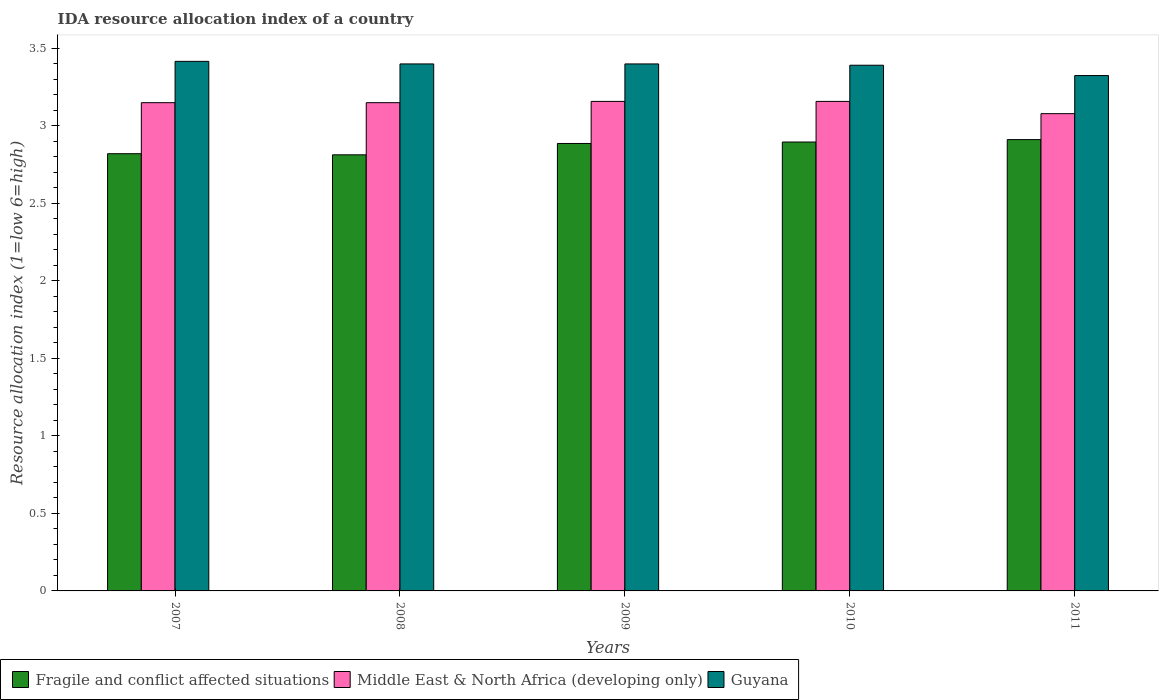How many groups of bars are there?
Your answer should be compact. 5. How many bars are there on the 1st tick from the right?
Provide a succinct answer. 3. What is the label of the 3rd group of bars from the left?
Provide a short and direct response. 2009. What is the IDA resource allocation index in Fragile and conflict affected situations in 2008?
Give a very brief answer. 2.81. Across all years, what is the maximum IDA resource allocation index in Guyana?
Offer a very short reply. 3.42. Across all years, what is the minimum IDA resource allocation index in Guyana?
Your answer should be compact. 3.33. In which year was the IDA resource allocation index in Fragile and conflict affected situations minimum?
Provide a short and direct response. 2008. What is the total IDA resource allocation index in Guyana in the graph?
Your response must be concise. 16.93. What is the difference between the IDA resource allocation index in Middle East & North Africa (developing only) in 2008 and that in 2011?
Give a very brief answer. 0.07. What is the difference between the IDA resource allocation index in Middle East & North Africa (developing only) in 2007 and the IDA resource allocation index in Guyana in 2010?
Your response must be concise. -0.24. What is the average IDA resource allocation index in Guyana per year?
Keep it short and to the point. 3.39. In the year 2008, what is the difference between the IDA resource allocation index in Fragile and conflict affected situations and IDA resource allocation index in Middle East & North Africa (developing only)?
Give a very brief answer. -0.34. In how many years, is the IDA resource allocation index in Fragile and conflict affected situations greater than 2.4?
Keep it short and to the point. 5. What is the ratio of the IDA resource allocation index in Guyana in 2009 to that in 2010?
Ensure brevity in your answer.  1. What is the difference between the highest and the second highest IDA resource allocation index in Fragile and conflict affected situations?
Keep it short and to the point. 0.02. What is the difference between the highest and the lowest IDA resource allocation index in Guyana?
Ensure brevity in your answer.  0.09. In how many years, is the IDA resource allocation index in Fragile and conflict affected situations greater than the average IDA resource allocation index in Fragile and conflict affected situations taken over all years?
Offer a terse response. 3. What does the 2nd bar from the left in 2010 represents?
Provide a short and direct response. Middle East & North Africa (developing only). What does the 1st bar from the right in 2011 represents?
Provide a short and direct response. Guyana. How many bars are there?
Make the answer very short. 15. Are all the bars in the graph horizontal?
Your response must be concise. No. What is the difference between two consecutive major ticks on the Y-axis?
Provide a succinct answer. 0.5. Are the values on the major ticks of Y-axis written in scientific E-notation?
Your response must be concise. No. Does the graph contain any zero values?
Ensure brevity in your answer.  No. Does the graph contain grids?
Your response must be concise. No. How many legend labels are there?
Offer a very short reply. 3. How are the legend labels stacked?
Your answer should be very brief. Horizontal. What is the title of the graph?
Offer a very short reply. IDA resource allocation index of a country. What is the label or title of the X-axis?
Keep it short and to the point. Years. What is the label or title of the Y-axis?
Your answer should be compact. Resource allocation index (1=low 6=high). What is the Resource allocation index (1=low 6=high) in Fragile and conflict affected situations in 2007?
Give a very brief answer. 2.82. What is the Resource allocation index (1=low 6=high) in Middle East & North Africa (developing only) in 2007?
Keep it short and to the point. 3.15. What is the Resource allocation index (1=low 6=high) in Guyana in 2007?
Give a very brief answer. 3.42. What is the Resource allocation index (1=low 6=high) of Fragile and conflict affected situations in 2008?
Give a very brief answer. 2.81. What is the Resource allocation index (1=low 6=high) in Middle East & North Africa (developing only) in 2008?
Ensure brevity in your answer.  3.15. What is the Resource allocation index (1=low 6=high) in Fragile and conflict affected situations in 2009?
Give a very brief answer. 2.89. What is the Resource allocation index (1=low 6=high) of Middle East & North Africa (developing only) in 2009?
Your response must be concise. 3.16. What is the Resource allocation index (1=low 6=high) of Guyana in 2009?
Provide a short and direct response. 3.4. What is the Resource allocation index (1=low 6=high) in Fragile and conflict affected situations in 2010?
Offer a terse response. 2.9. What is the Resource allocation index (1=low 6=high) of Middle East & North Africa (developing only) in 2010?
Ensure brevity in your answer.  3.16. What is the Resource allocation index (1=low 6=high) in Guyana in 2010?
Offer a terse response. 3.39. What is the Resource allocation index (1=low 6=high) in Fragile and conflict affected situations in 2011?
Make the answer very short. 2.91. What is the Resource allocation index (1=low 6=high) of Middle East & North Africa (developing only) in 2011?
Ensure brevity in your answer.  3.08. What is the Resource allocation index (1=low 6=high) in Guyana in 2011?
Offer a very short reply. 3.33. Across all years, what is the maximum Resource allocation index (1=low 6=high) in Fragile and conflict affected situations?
Offer a very short reply. 2.91. Across all years, what is the maximum Resource allocation index (1=low 6=high) of Middle East & North Africa (developing only)?
Offer a very short reply. 3.16. Across all years, what is the maximum Resource allocation index (1=low 6=high) of Guyana?
Keep it short and to the point. 3.42. Across all years, what is the minimum Resource allocation index (1=low 6=high) in Fragile and conflict affected situations?
Provide a succinct answer. 2.81. Across all years, what is the minimum Resource allocation index (1=low 6=high) in Middle East & North Africa (developing only)?
Your answer should be very brief. 3.08. Across all years, what is the minimum Resource allocation index (1=low 6=high) in Guyana?
Provide a short and direct response. 3.33. What is the total Resource allocation index (1=low 6=high) in Fragile and conflict affected situations in the graph?
Provide a succinct answer. 14.33. What is the total Resource allocation index (1=low 6=high) in Middle East & North Africa (developing only) in the graph?
Offer a very short reply. 15.7. What is the total Resource allocation index (1=low 6=high) in Guyana in the graph?
Provide a succinct answer. 16.93. What is the difference between the Resource allocation index (1=low 6=high) in Fragile and conflict affected situations in 2007 and that in 2008?
Provide a short and direct response. 0.01. What is the difference between the Resource allocation index (1=low 6=high) in Guyana in 2007 and that in 2008?
Your answer should be compact. 0.02. What is the difference between the Resource allocation index (1=low 6=high) of Fragile and conflict affected situations in 2007 and that in 2009?
Your answer should be compact. -0.07. What is the difference between the Resource allocation index (1=low 6=high) of Middle East & North Africa (developing only) in 2007 and that in 2009?
Your answer should be compact. -0.01. What is the difference between the Resource allocation index (1=low 6=high) in Guyana in 2007 and that in 2009?
Offer a very short reply. 0.02. What is the difference between the Resource allocation index (1=low 6=high) of Fragile and conflict affected situations in 2007 and that in 2010?
Provide a short and direct response. -0.08. What is the difference between the Resource allocation index (1=low 6=high) of Middle East & North Africa (developing only) in 2007 and that in 2010?
Keep it short and to the point. -0.01. What is the difference between the Resource allocation index (1=low 6=high) in Guyana in 2007 and that in 2010?
Ensure brevity in your answer.  0.03. What is the difference between the Resource allocation index (1=low 6=high) of Fragile and conflict affected situations in 2007 and that in 2011?
Your answer should be very brief. -0.09. What is the difference between the Resource allocation index (1=low 6=high) of Middle East & North Africa (developing only) in 2007 and that in 2011?
Keep it short and to the point. 0.07. What is the difference between the Resource allocation index (1=low 6=high) in Guyana in 2007 and that in 2011?
Your answer should be compact. 0.09. What is the difference between the Resource allocation index (1=low 6=high) in Fragile and conflict affected situations in 2008 and that in 2009?
Offer a very short reply. -0.07. What is the difference between the Resource allocation index (1=low 6=high) of Middle East & North Africa (developing only) in 2008 and that in 2009?
Offer a very short reply. -0.01. What is the difference between the Resource allocation index (1=low 6=high) of Guyana in 2008 and that in 2009?
Your response must be concise. 0. What is the difference between the Resource allocation index (1=low 6=high) in Fragile and conflict affected situations in 2008 and that in 2010?
Your answer should be compact. -0.08. What is the difference between the Resource allocation index (1=low 6=high) of Middle East & North Africa (developing only) in 2008 and that in 2010?
Provide a short and direct response. -0.01. What is the difference between the Resource allocation index (1=low 6=high) in Guyana in 2008 and that in 2010?
Provide a succinct answer. 0.01. What is the difference between the Resource allocation index (1=low 6=high) of Fragile and conflict affected situations in 2008 and that in 2011?
Keep it short and to the point. -0.1. What is the difference between the Resource allocation index (1=low 6=high) in Middle East & North Africa (developing only) in 2008 and that in 2011?
Offer a very short reply. 0.07. What is the difference between the Resource allocation index (1=low 6=high) of Guyana in 2008 and that in 2011?
Offer a very short reply. 0.07. What is the difference between the Resource allocation index (1=low 6=high) of Fragile and conflict affected situations in 2009 and that in 2010?
Your answer should be compact. -0.01. What is the difference between the Resource allocation index (1=low 6=high) in Guyana in 2009 and that in 2010?
Offer a very short reply. 0.01. What is the difference between the Resource allocation index (1=low 6=high) in Fragile and conflict affected situations in 2009 and that in 2011?
Give a very brief answer. -0.03. What is the difference between the Resource allocation index (1=low 6=high) in Middle East & North Africa (developing only) in 2009 and that in 2011?
Your response must be concise. 0.08. What is the difference between the Resource allocation index (1=low 6=high) of Guyana in 2009 and that in 2011?
Make the answer very short. 0.07. What is the difference between the Resource allocation index (1=low 6=high) in Fragile and conflict affected situations in 2010 and that in 2011?
Provide a short and direct response. -0.02. What is the difference between the Resource allocation index (1=low 6=high) in Middle East & North Africa (developing only) in 2010 and that in 2011?
Offer a terse response. 0.08. What is the difference between the Resource allocation index (1=low 6=high) of Guyana in 2010 and that in 2011?
Give a very brief answer. 0.07. What is the difference between the Resource allocation index (1=low 6=high) in Fragile and conflict affected situations in 2007 and the Resource allocation index (1=low 6=high) in Middle East & North Africa (developing only) in 2008?
Offer a very short reply. -0.33. What is the difference between the Resource allocation index (1=low 6=high) in Fragile and conflict affected situations in 2007 and the Resource allocation index (1=low 6=high) in Guyana in 2008?
Give a very brief answer. -0.58. What is the difference between the Resource allocation index (1=low 6=high) in Middle East & North Africa (developing only) in 2007 and the Resource allocation index (1=low 6=high) in Guyana in 2008?
Offer a very short reply. -0.25. What is the difference between the Resource allocation index (1=low 6=high) in Fragile and conflict affected situations in 2007 and the Resource allocation index (1=low 6=high) in Middle East & North Africa (developing only) in 2009?
Keep it short and to the point. -0.34. What is the difference between the Resource allocation index (1=low 6=high) in Fragile and conflict affected situations in 2007 and the Resource allocation index (1=low 6=high) in Guyana in 2009?
Ensure brevity in your answer.  -0.58. What is the difference between the Resource allocation index (1=low 6=high) of Fragile and conflict affected situations in 2007 and the Resource allocation index (1=low 6=high) of Middle East & North Africa (developing only) in 2010?
Offer a very short reply. -0.34. What is the difference between the Resource allocation index (1=low 6=high) of Fragile and conflict affected situations in 2007 and the Resource allocation index (1=low 6=high) of Guyana in 2010?
Keep it short and to the point. -0.57. What is the difference between the Resource allocation index (1=low 6=high) in Middle East & North Africa (developing only) in 2007 and the Resource allocation index (1=low 6=high) in Guyana in 2010?
Offer a very short reply. -0.24. What is the difference between the Resource allocation index (1=low 6=high) in Fragile and conflict affected situations in 2007 and the Resource allocation index (1=low 6=high) in Middle East & North Africa (developing only) in 2011?
Provide a short and direct response. -0.26. What is the difference between the Resource allocation index (1=low 6=high) of Fragile and conflict affected situations in 2007 and the Resource allocation index (1=low 6=high) of Guyana in 2011?
Provide a succinct answer. -0.5. What is the difference between the Resource allocation index (1=low 6=high) of Middle East & North Africa (developing only) in 2007 and the Resource allocation index (1=low 6=high) of Guyana in 2011?
Offer a terse response. -0.17. What is the difference between the Resource allocation index (1=low 6=high) of Fragile and conflict affected situations in 2008 and the Resource allocation index (1=low 6=high) of Middle East & North Africa (developing only) in 2009?
Provide a succinct answer. -0.34. What is the difference between the Resource allocation index (1=low 6=high) of Fragile and conflict affected situations in 2008 and the Resource allocation index (1=low 6=high) of Guyana in 2009?
Your response must be concise. -0.59. What is the difference between the Resource allocation index (1=low 6=high) of Fragile and conflict affected situations in 2008 and the Resource allocation index (1=low 6=high) of Middle East & North Africa (developing only) in 2010?
Keep it short and to the point. -0.34. What is the difference between the Resource allocation index (1=low 6=high) of Fragile and conflict affected situations in 2008 and the Resource allocation index (1=low 6=high) of Guyana in 2010?
Provide a short and direct response. -0.58. What is the difference between the Resource allocation index (1=low 6=high) of Middle East & North Africa (developing only) in 2008 and the Resource allocation index (1=low 6=high) of Guyana in 2010?
Your answer should be compact. -0.24. What is the difference between the Resource allocation index (1=low 6=high) in Fragile and conflict affected situations in 2008 and the Resource allocation index (1=low 6=high) in Middle East & North Africa (developing only) in 2011?
Your response must be concise. -0.27. What is the difference between the Resource allocation index (1=low 6=high) of Fragile and conflict affected situations in 2008 and the Resource allocation index (1=low 6=high) of Guyana in 2011?
Keep it short and to the point. -0.51. What is the difference between the Resource allocation index (1=low 6=high) of Middle East & North Africa (developing only) in 2008 and the Resource allocation index (1=low 6=high) of Guyana in 2011?
Your response must be concise. -0.17. What is the difference between the Resource allocation index (1=low 6=high) of Fragile and conflict affected situations in 2009 and the Resource allocation index (1=low 6=high) of Middle East & North Africa (developing only) in 2010?
Your answer should be very brief. -0.27. What is the difference between the Resource allocation index (1=low 6=high) in Fragile and conflict affected situations in 2009 and the Resource allocation index (1=low 6=high) in Guyana in 2010?
Provide a short and direct response. -0.5. What is the difference between the Resource allocation index (1=low 6=high) of Middle East & North Africa (developing only) in 2009 and the Resource allocation index (1=low 6=high) of Guyana in 2010?
Your answer should be very brief. -0.23. What is the difference between the Resource allocation index (1=low 6=high) of Fragile and conflict affected situations in 2009 and the Resource allocation index (1=low 6=high) of Middle East & North Africa (developing only) in 2011?
Provide a succinct answer. -0.19. What is the difference between the Resource allocation index (1=low 6=high) of Fragile and conflict affected situations in 2009 and the Resource allocation index (1=low 6=high) of Guyana in 2011?
Your answer should be very brief. -0.44. What is the difference between the Resource allocation index (1=low 6=high) of Fragile and conflict affected situations in 2010 and the Resource allocation index (1=low 6=high) of Middle East & North Africa (developing only) in 2011?
Make the answer very short. -0.18. What is the difference between the Resource allocation index (1=low 6=high) of Fragile and conflict affected situations in 2010 and the Resource allocation index (1=low 6=high) of Guyana in 2011?
Provide a short and direct response. -0.43. What is the average Resource allocation index (1=low 6=high) of Fragile and conflict affected situations per year?
Provide a short and direct response. 2.87. What is the average Resource allocation index (1=low 6=high) of Middle East & North Africa (developing only) per year?
Offer a very short reply. 3.14. What is the average Resource allocation index (1=low 6=high) in Guyana per year?
Your answer should be compact. 3.39. In the year 2007, what is the difference between the Resource allocation index (1=low 6=high) of Fragile and conflict affected situations and Resource allocation index (1=low 6=high) of Middle East & North Africa (developing only)?
Provide a succinct answer. -0.33. In the year 2007, what is the difference between the Resource allocation index (1=low 6=high) of Fragile and conflict affected situations and Resource allocation index (1=low 6=high) of Guyana?
Your answer should be compact. -0.6. In the year 2007, what is the difference between the Resource allocation index (1=low 6=high) in Middle East & North Africa (developing only) and Resource allocation index (1=low 6=high) in Guyana?
Make the answer very short. -0.27. In the year 2008, what is the difference between the Resource allocation index (1=low 6=high) in Fragile and conflict affected situations and Resource allocation index (1=low 6=high) in Middle East & North Africa (developing only)?
Keep it short and to the point. -0.34. In the year 2008, what is the difference between the Resource allocation index (1=low 6=high) of Fragile and conflict affected situations and Resource allocation index (1=low 6=high) of Guyana?
Ensure brevity in your answer.  -0.59. In the year 2008, what is the difference between the Resource allocation index (1=low 6=high) in Middle East & North Africa (developing only) and Resource allocation index (1=low 6=high) in Guyana?
Offer a very short reply. -0.25. In the year 2009, what is the difference between the Resource allocation index (1=low 6=high) in Fragile and conflict affected situations and Resource allocation index (1=low 6=high) in Middle East & North Africa (developing only)?
Offer a terse response. -0.27. In the year 2009, what is the difference between the Resource allocation index (1=low 6=high) of Fragile and conflict affected situations and Resource allocation index (1=low 6=high) of Guyana?
Provide a short and direct response. -0.51. In the year 2009, what is the difference between the Resource allocation index (1=low 6=high) in Middle East & North Africa (developing only) and Resource allocation index (1=low 6=high) in Guyana?
Offer a terse response. -0.24. In the year 2010, what is the difference between the Resource allocation index (1=low 6=high) in Fragile and conflict affected situations and Resource allocation index (1=low 6=high) in Middle East & North Africa (developing only)?
Make the answer very short. -0.26. In the year 2010, what is the difference between the Resource allocation index (1=low 6=high) of Fragile and conflict affected situations and Resource allocation index (1=low 6=high) of Guyana?
Give a very brief answer. -0.5. In the year 2010, what is the difference between the Resource allocation index (1=low 6=high) in Middle East & North Africa (developing only) and Resource allocation index (1=low 6=high) in Guyana?
Your response must be concise. -0.23. In the year 2011, what is the difference between the Resource allocation index (1=low 6=high) of Fragile and conflict affected situations and Resource allocation index (1=low 6=high) of Middle East & North Africa (developing only)?
Keep it short and to the point. -0.17. In the year 2011, what is the difference between the Resource allocation index (1=low 6=high) of Fragile and conflict affected situations and Resource allocation index (1=low 6=high) of Guyana?
Ensure brevity in your answer.  -0.41. In the year 2011, what is the difference between the Resource allocation index (1=low 6=high) of Middle East & North Africa (developing only) and Resource allocation index (1=low 6=high) of Guyana?
Provide a short and direct response. -0.25. What is the ratio of the Resource allocation index (1=low 6=high) in Fragile and conflict affected situations in 2007 to that in 2008?
Provide a succinct answer. 1. What is the ratio of the Resource allocation index (1=low 6=high) in Guyana in 2007 to that in 2008?
Provide a short and direct response. 1. What is the ratio of the Resource allocation index (1=low 6=high) of Fragile and conflict affected situations in 2007 to that in 2009?
Ensure brevity in your answer.  0.98. What is the ratio of the Resource allocation index (1=low 6=high) of Guyana in 2007 to that in 2010?
Provide a succinct answer. 1.01. What is the ratio of the Resource allocation index (1=low 6=high) in Fragile and conflict affected situations in 2007 to that in 2011?
Provide a short and direct response. 0.97. What is the ratio of the Resource allocation index (1=low 6=high) in Middle East & North Africa (developing only) in 2007 to that in 2011?
Ensure brevity in your answer.  1.02. What is the ratio of the Resource allocation index (1=low 6=high) of Guyana in 2007 to that in 2011?
Your response must be concise. 1.03. What is the ratio of the Resource allocation index (1=low 6=high) of Fragile and conflict affected situations in 2008 to that in 2009?
Your answer should be compact. 0.97. What is the ratio of the Resource allocation index (1=low 6=high) in Middle East & North Africa (developing only) in 2008 to that in 2009?
Ensure brevity in your answer.  1. What is the ratio of the Resource allocation index (1=low 6=high) of Fragile and conflict affected situations in 2008 to that in 2010?
Offer a very short reply. 0.97. What is the ratio of the Resource allocation index (1=low 6=high) of Fragile and conflict affected situations in 2008 to that in 2011?
Keep it short and to the point. 0.97. What is the ratio of the Resource allocation index (1=low 6=high) in Guyana in 2008 to that in 2011?
Provide a short and direct response. 1.02. What is the ratio of the Resource allocation index (1=low 6=high) in Middle East & North Africa (developing only) in 2009 to that in 2010?
Give a very brief answer. 1. What is the ratio of the Resource allocation index (1=low 6=high) of Guyana in 2009 to that in 2010?
Offer a very short reply. 1. What is the ratio of the Resource allocation index (1=low 6=high) of Fragile and conflict affected situations in 2009 to that in 2011?
Your answer should be very brief. 0.99. What is the ratio of the Resource allocation index (1=low 6=high) in Middle East & North Africa (developing only) in 2009 to that in 2011?
Provide a succinct answer. 1.03. What is the ratio of the Resource allocation index (1=low 6=high) of Guyana in 2009 to that in 2011?
Provide a short and direct response. 1.02. What is the ratio of the Resource allocation index (1=low 6=high) in Fragile and conflict affected situations in 2010 to that in 2011?
Your answer should be compact. 0.99. What is the ratio of the Resource allocation index (1=low 6=high) of Middle East & North Africa (developing only) in 2010 to that in 2011?
Offer a terse response. 1.03. What is the ratio of the Resource allocation index (1=low 6=high) in Guyana in 2010 to that in 2011?
Your answer should be very brief. 1.02. What is the difference between the highest and the second highest Resource allocation index (1=low 6=high) in Fragile and conflict affected situations?
Keep it short and to the point. 0.02. What is the difference between the highest and the second highest Resource allocation index (1=low 6=high) of Middle East & North Africa (developing only)?
Keep it short and to the point. 0. What is the difference between the highest and the second highest Resource allocation index (1=low 6=high) in Guyana?
Make the answer very short. 0.02. What is the difference between the highest and the lowest Resource allocation index (1=low 6=high) in Fragile and conflict affected situations?
Make the answer very short. 0.1. What is the difference between the highest and the lowest Resource allocation index (1=low 6=high) in Middle East & North Africa (developing only)?
Ensure brevity in your answer.  0.08. What is the difference between the highest and the lowest Resource allocation index (1=low 6=high) in Guyana?
Provide a short and direct response. 0.09. 